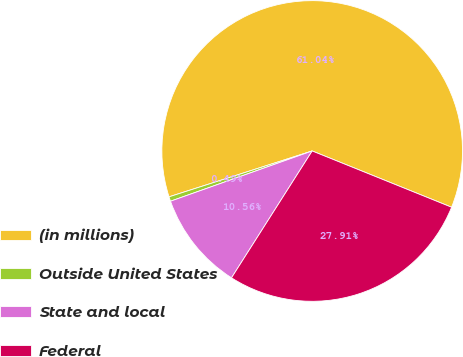<chart> <loc_0><loc_0><loc_500><loc_500><pie_chart><fcel>(in millions)<fcel>Outside United States<fcel>State and local<fcel>Federal<nl><fcel>61.04%<fcel>0.49%<fcel>10.56%<fcel>27.91%<nl></chart> 